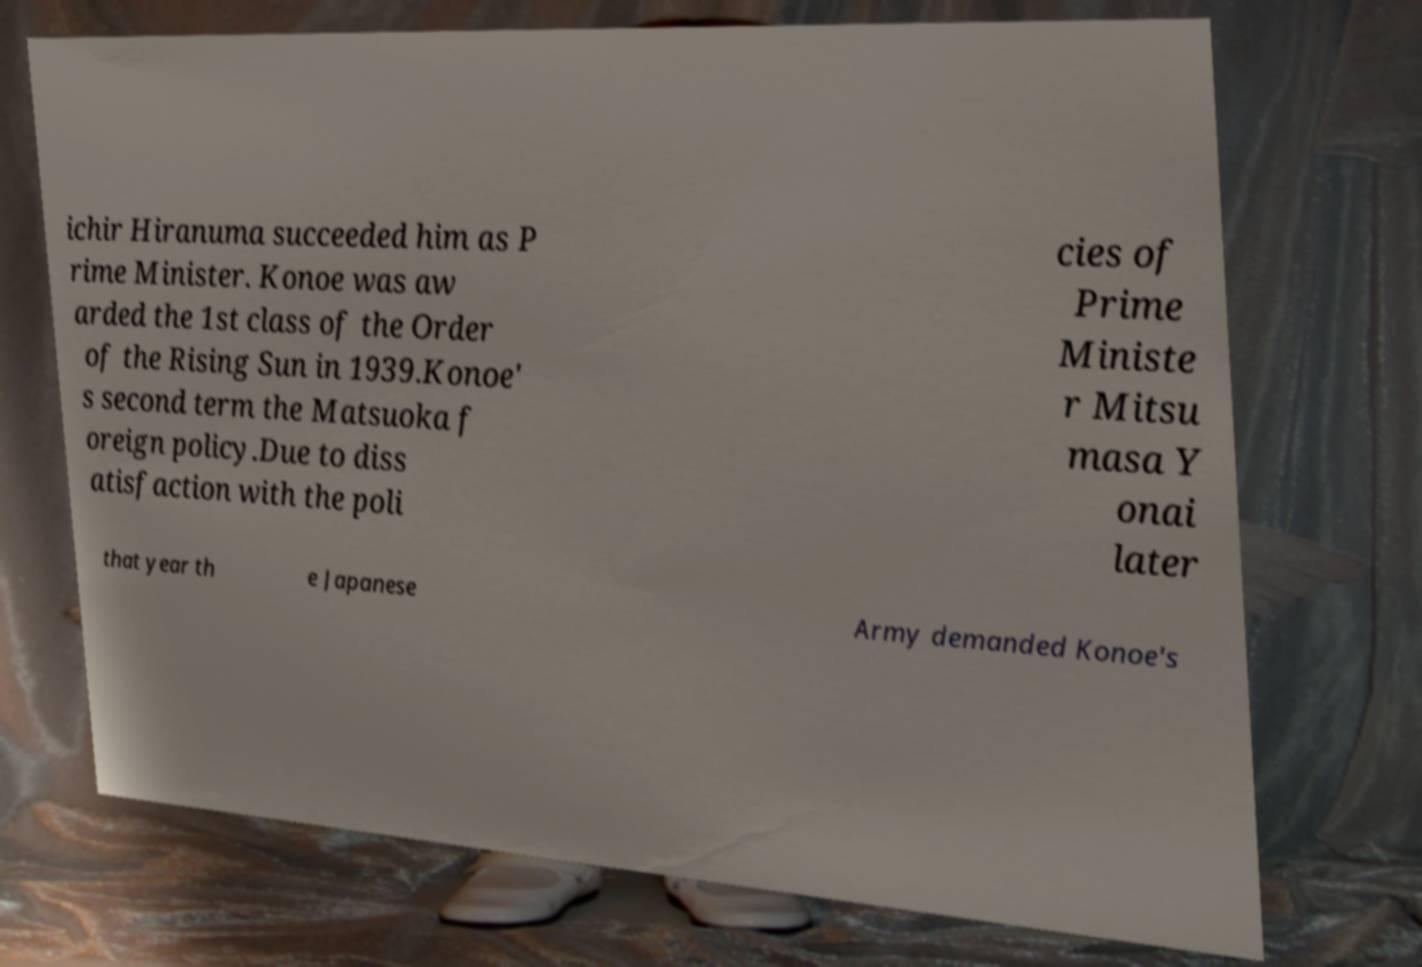Can you accurately transcribe the text from the provided image for me? ichir Hiranuma succeeded him as P rime Minister. Konoe was aw arded the 1st class of the Order of the Rising Sun in 1939.Konoe' s second term the Matsuoka f oreign policy.Due to diss atisfaction with the poli cies of Prime Ministe r Mitsu masa Y onai later that year th e Japanese Army demanded Konoe's 